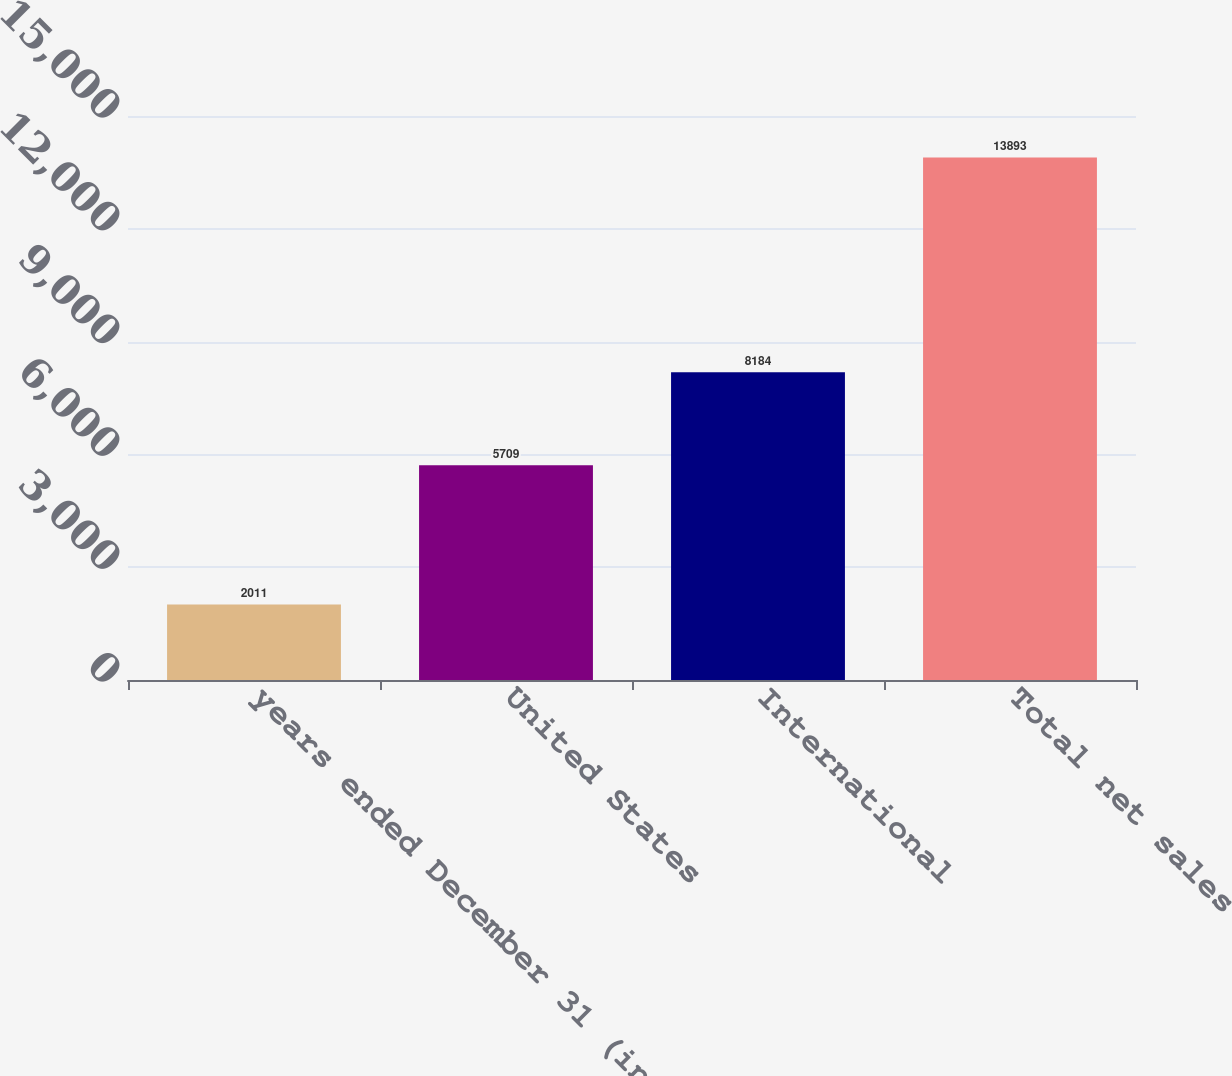Convert chart to OTSL. <chart><loc_0><loc_0><loc_500><loc_500><bar_chart><fcel>years ended December 31 (in<fcel>United States<fcel>International<fcel>Total net sales<nl><fcel>2011<fcel>5709<fcel>8184<fcel>13893<nl></chart> 